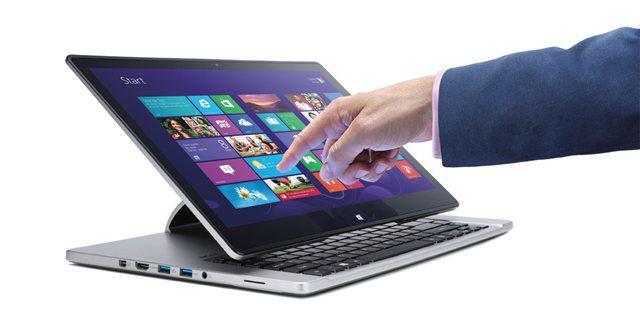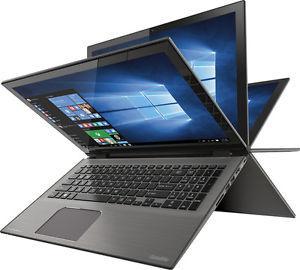The first image is the image on the left, the second image is the image on the right. Assess this claim about the two images: "Right image shows a laptop displayed like an inverted book with its pages fanning out.". Correct or not? Answer yes or no. Yes. The first image is the image on the left, the second image is the image on the right. Evaluate the accuracy of this statement regarding the images: "A pen is touching the screen in one of the images.". Is it true? Answer yes or no. No. 